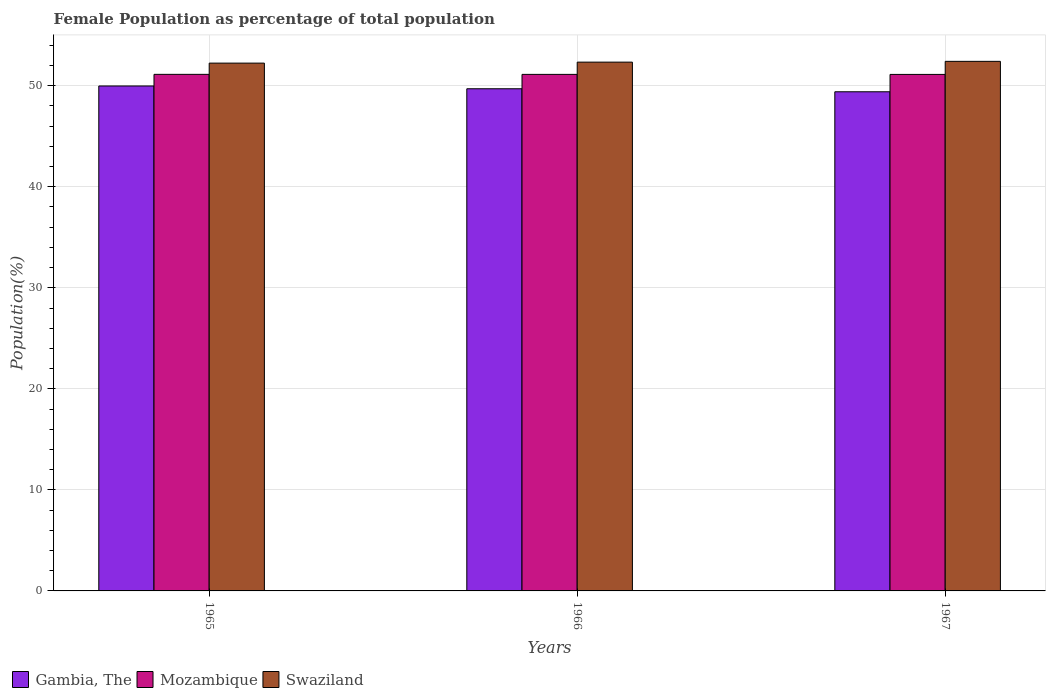How many different coloured bars are there?
Make the answer very short. 3. What is the label of the 2nd group of bars from the left?
Offer a very short reply. 1966. In how many cases, is the number of bars for a given year not equal to the number of legend labels?
Provide a short and direct response. 0. What is the female population in in Gambia, The in 1965?
Offer a terse response. 49.98. Across all years, what is the maximum female population in in Mozambique?
Keep it short and to the point. 51.13. Across all years, what is the minimum female population in in Swaziland?
Your answer should be very brief. 52.24. In which year was the female population in in Mozambique maximum?
Give a very brief answer. 1965. In which year was the female population in in Swaziland minimum?
Keep it short and to the point. 1965. What is the total female population in in Mozambique in the graph?
Your answer should be compact. 153.37. What is the difference between the female population in in Gambia, The in 1966 and that in 1967?
Your response must be concise. 0.3. What is the difference between the female population in in Mozambique in 1965 and the female population in in Swaziland in 1967?
Provide a short and direct response. -1.29. What is the average female population in in Gambia, The per year?
Your answer should be very brief. 49.69. In the year 1966, what is the difference between the female population in in Gambia, The and female population in in Swaziland?
Your response must be concise. -2.64. What is the ratio of the female population in in Swaziland in 1966 to that in 1967?
Make the answer very short. 1. Is the female population in in Gambia, The in 1965 less than that in 1966?
Your answer should be very brief. No. Is the difference between the female population in in Gambia, The in 1965 and 1966 greater than the difference between the female population in in Swaziland in 1965 and 1966?
Offer a very short reply. Yes. What is the difference between the highest and the second highest female population in in Mozambique?
Provide a succinct answer. 0. What is the difference between the highest and the lowest female population in in Swaziland?
Provide a short and direct response. 0.17. What does the 1st bar from the left in 1966 represents?
Ensure brevity in your answer.  Gambia, The. What does the 3rd bar from the right in 1965 represents?
Give a very brief answer. Gambia, The. How many bars are there?
Provide a short and direct response. 9. Are all the bars in the graph horizontal?
Offer a terse response. No. How many years are there in the graph?
Provide a succinct answer. 3. Where does the legend appear in the graph?
Give a very brief answer. Bottom left. What is the title of the graph?
Your answer should be compact. Female Population as percentage of total population. Does "Fragile and conflict affected situations" appear as one of the legend labels in the graph?
Give a very brief answer. No. What is the label or title of the X-axis?
Provide a short and direct response. Years. What is the label or title of the Y-axis?
Make the answer very short. Population(%). What is the Population(%) in Gambia, The in 1965?
Your answer should be compact. 49.98. What is the Population(%) of Mozambique in 1965?
Make the answer very short. 51.13. What is the Population(%) of Swaziland in 1965?
Your answer should be very brief. 52.24. What is the Population(%) in Gambia, The in 1966?
Your answer should be very brief. 49.7. What is the Population(%) of Mozambique in 1966?
Make the answer very short. 51.12. What is the Population(%) of Swaziland in 1966?
Provide a short and direct response. 52.34. What is the Population(%) in Gambia, The in 1967?
Provide a short and direct response. 49.4. What is the Population(%) in Mozambique in 1967?
Offer a terse response. 51.12. What is the Population(%) in Swaziland in 1967?
Offer a very short reply. 52.41. Across all years, what is the maximum Population(%) of Gambia, The?
Your answer should be compact. 49.98. Across all years, what is the maximum Population(%) of Mozambique?
Ensure brevity in your answer.  51.13. Across all years, what is the maximum Population(%) in Swaziland?
Your answer should be compact. 52.41. Across all years, what is the minimum Population(%) in Gambia, The?
Your answer should be very brief. 49.4. Across all years, what is the minimum Population(%) in Mozambique?
Offer a very short reply. 51.12. Across all years, what is the minimum Population(%) in Swaziland?
Your answer should be compact. 52.24. What is the total Population(%) in Gambia, The in the graph?
Your response must be concise. 149.08. What is the total Population(%) in Mozambique in the graph?
Provide a succinct answer. 153.37. What is the total Population(%) of Swaziland in the graph?
Offer a terse response. 156.99. What is the difference between the Population(%) of Gambia, The in 1965 and that in 1966?
Offer a terse response. 0.27. What is the difference between the Population(%) of Mozambique in 1965 and that in 1966?
Your response must be concise. 0. What is the difference between the Population(%) in Swaziland in 1965 and that in 1966?
Make the answer very short. -0.1. What is the difference between the Population(%) of Gambia, The in 1965 and that in 1967?
Your response must be concise. 0.57. What is the difference between the Population(%) of Mozambique in 1965 and that in 1967?
Your response must be concise. 0.01. What is the difference between the Population(%) in Swaziland in 1965 and that in 1967?
Make the answer very short. -0.17. What is the difference between the Population(%) of Gambia, The in 1966 and that in 1967?
Your answer should be very brief. 0.3. What is the difference between the Population(%) in Mozambique in 1966 and that in 1967?
Offer a terse response. 0. What is the difference between the Population(%) of Swaziland in 1966 and that in 1967?
Your answer should be very brief. -0.08. What is the difference between the Population(%) in Gambia, The in 1965 and the Population(%) in Mozambique in 1966?
Provide a succinct answer. -1.15. What is the difference between the Population(%) in Gambia, The in 1965 and the Population(%) in Swaziland in 1966?
Provide a succinct answer. -2.36. What is the difference between the Population(%) in Mozambique in 1965 and the Population(%) in Swaziland in 1966?
Provide a short and direct response. -1.21. What is the difference between the Population(%) in Gambia, The in 1965 and the Population(%) in Mozambique in 1967?
Provide a succinct answer. -1.14. What is the difference between the Population(%) of Gambia, The in 1965 and the Population(%) of Swaziland in 1967?
Ensure brevity in your answer.  -2.44. What is the difference between the Population(%) of Mozambique in 1965 and the Population(%) of Swaziland in 1967?
Offer a terse response. -1.29. What is the difference between the Population(%) of Gambia, The in 1966 and the Population(%) of Mozambique in 1967?
Offer a very short reply. -1.42. What is the difference between the Population(%) in Gambia, The in 1966 and the Population(%) in Swaziland in 1967?
Your answer should be very brief. -2.71. What is the difference between the Population(%) in Mozambique in 1966 and the Population(%) in Swaziland in 1967?
Your response must be concise. -1.29. What is the average Population(%) in Gambia, The per year?
Keep it short and to the point. 49.69. What is the average Population(%) in Mozambique per year?
Your response must be concise. 51.12. What is the average Population(%) of Swaziland per year?
Your response must be concise. 52.33. In the year 1965, what is the difference between the Population(%) of Gambia, The and Population(%) of Mozambique?
Offer a very short reply. -1.15. In the year 1965, what is the difference between the Population(%) in Gambia, The and Population(%) in Swaziland?
Offer a terse response. -2.26. In the year 1965, what is the difference between the Population(%) of Mozambique and Population(%) of Swaziland?
Provide a short and direct response. -1.11. In the year 1966, what is the difference between the Population(%) in Gambia, The and Population(%) in Mozambique?
Keep it short and to the point. -1.42. In the year 1966, what is the difference between the Population(%) of Gambia, The and Population(%) of Swaziland?
Ensure brevity in your answer.  -2.64. In the year 1966, what is the difference between the Population(%) of Mozambique and Population(%) of Swaziland?
Your answer should be compact. -1.21. In the year 1967, what is the difference between the Population(%) of Gambia, The and Population(%) of Mozambique?
Your answer should be compact. -1.72. In the year 1967, what is the difference between the Population(%) in Gambia, The and Population(%) in Swaziland?
Ensure brevity in your answer.  -3.01. In the year 1967, what is the difference between the Population(%) of Mozambique and Population(%) of Swaziland?
Keep it short and to the point. -1.29. What is the ratio of the Population(%) in Mozambique in 1965 to that in 1966?
Your answer should be compact. 1. What is the ratio of the Population(%) of Gambia, The in 1965 to that in 1967?
Ensure brevity in your answer.  1.01. What is the ratio of the Population(%) of Swaziland in 1965 to that in 1967?
Offer a terse response. 1. What is the ratio of the Population(%) of Gambia, The in 1966 to that in 1967?
Keep it short and to the point. 1.01. What is the ratio of the Population(%) of Mozambique in 1966 to that in 1967?
Your response must be concise. 1. What is the difference between the highest and the second highest Population(%) in Gambia, The?
Your response must be concise. 0.27. What is the difference between the highest and the second highest Population(%) in Mozambique?
Keep it short and to the point. 0. What is the difference between the highest and the second highest Population(%) in Swaziland?
Provide a succinct answer. 0.08. What is the difference between the highest and the lowest Population(%) of Gambia, The?
Make the answer very short. 0.57. What is the difference between the highest and the lowest Population(%) in Mozambique?
Ensure brevity in your answer.  0.01. What is the difference between the highest and the lowest Population(%) of Swaziland?
Provide a succinct answer. 0.17. 